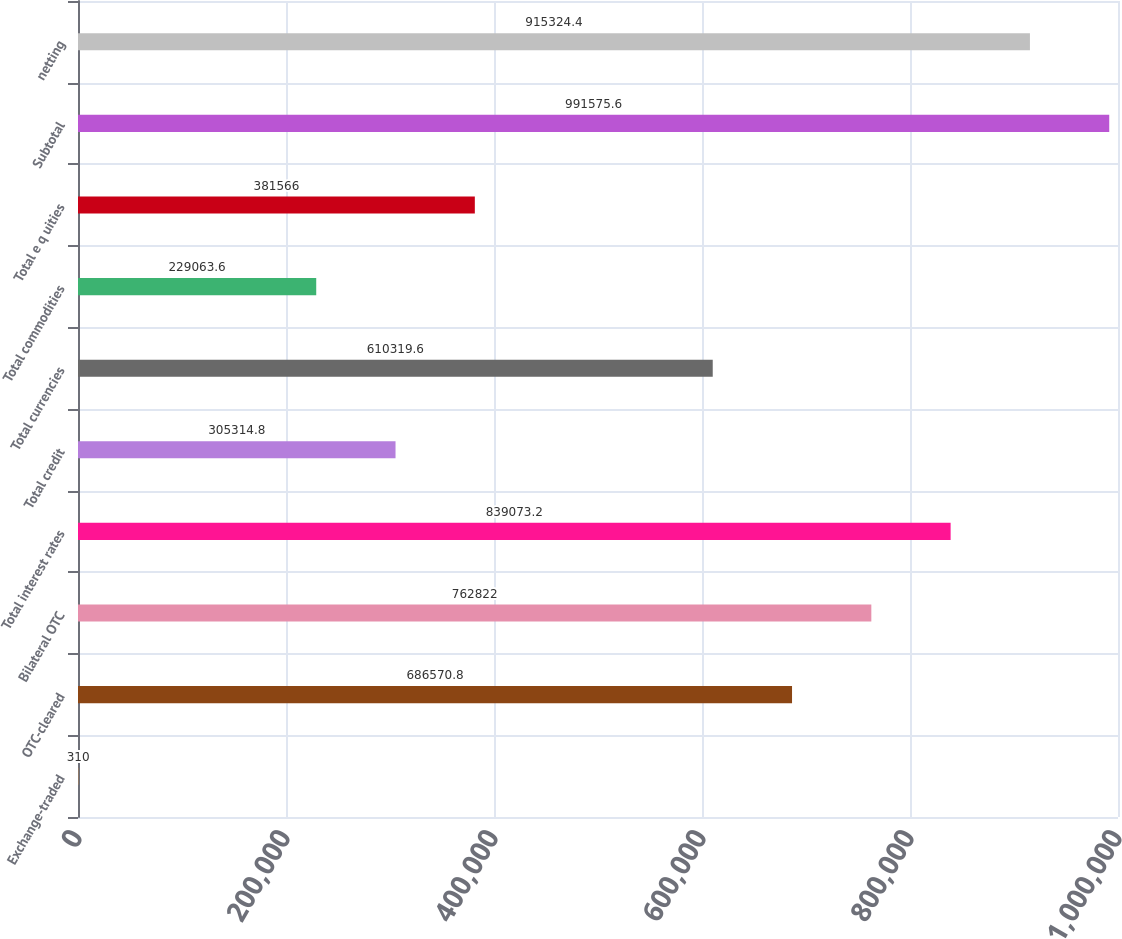<chart> <loc_0><loc_0><loc_500><loc_500><bar_chart><fcel>Exchange-traded<fcel>OTC-cleared<fcel>Bilateral OTC<fcel>Total interest rates<fcel>Total credit<fcel>Total currencies<fcel>Total commodities<fcel>Total e q uities<fcel>Subtotal<fcel>netting<nl><fcel>310<fcel>686571<fcel>762822<fcel>839073<fcel>305315<fcel>610320<fcel>229064<fcel>381566<fcel>991576<fcel>915324<nl></chart> 